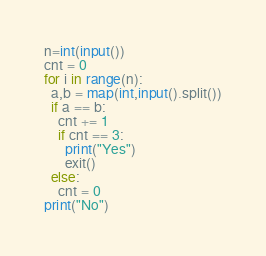Convert code to text. <code><loc_0><loc_0><loc_500><loc_500><_Python_>n=int(input())
cnt = 0
for i in range(n):
  a,b = map(int,input().split())
  if a == b:
    cnt += 1
    if cnt == 3:
      print("Yes")
      exit()
  else:
    cnt = 0
print("No")</code> 